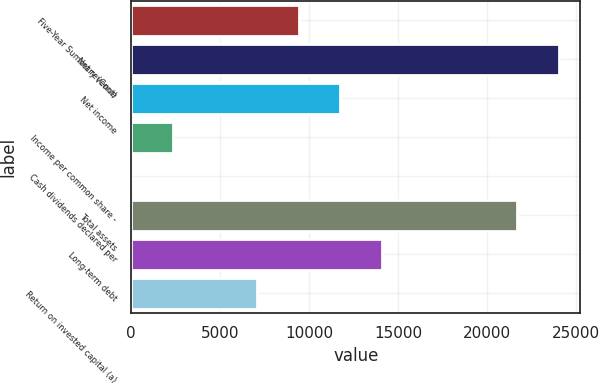Convert chart to OTSL. <chart><loc_0><loc_0><loc_500><loc_500><bar_chart><fcel>Five-Year Summary (Cont)<fcel>Net revenue<fcel>Net income<fcel>Income per common share -<fcel>Cash dividends declared per<fcel>Total assets<fcel>Long-term debt<fcel>Return on invested capital (a)<nl><fcel>9405.13<fcel>24046.1<fcel>11756.3<fcel>2351.71<fcel>0.57<fcel>21695<fcel>14107.4<fcel>7053.99<nl></chart> 